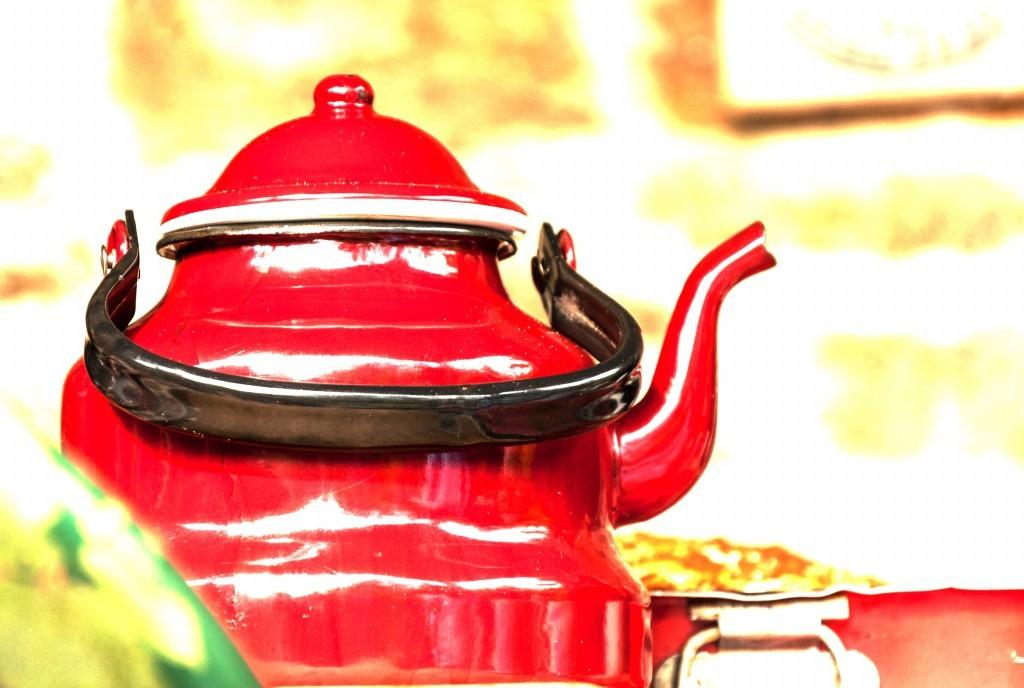What is the main object in the image? There is a tea kettle in the image. What features does the tea kettle have? The tea kettle has a lid and a handle. What can be said about the background of the image? The background of the image is blurred. What type of material is used to make the tea kettle? Metal objects are present in the image, which suggests that the tea kettle is made of metal. Where is the calendar located in the image? There is no calendar present in the image. What type of ice can be seen melting on the tea kettle? There is no ice present in the image, and the tea kettle is not melting. 